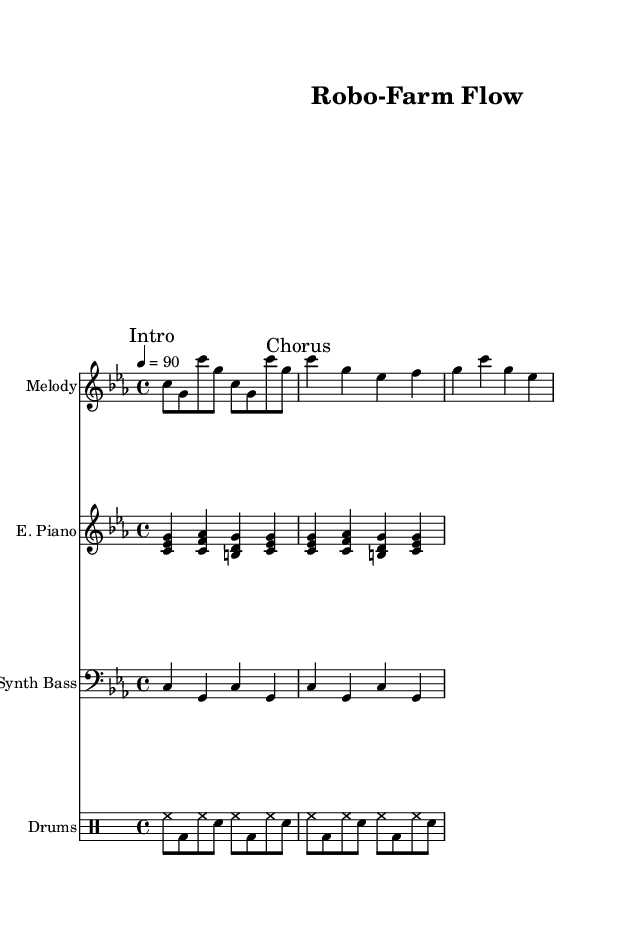What is the key signature of this music? The key signature is indicated at the beginning of the sheet music, and it shows C minor, which has three flats: B flat, E flat, and A flat.
Answer: C minor What is the time signature of this music? The time signature appears next to the key signature in the beginning section, showing it is 4/4, which means there are four beats per measure and the quarter note gets one beat.
Answer: 4/4 What is the tempo marking of this music? The tempo marking is found above the staff and is indicated by the number 90, meaning the music should be played at 90 beats per minute.
Answer: 90 How many measures are in the melody section? Counting the measures in the melody part leads to a total of four measures labeled "Intro" and four measures labeled "Chorus," resulting in eight measures overall in that section.
Answer: 8 What instruments are used in the piece? The instruments are listed at the beginning of each staff, including "Melody," "E. Piano," "Synth Bass," and "Drums," indicating a varied hip hop ensemble.
Answer: Melody, E. Piano, Synth Bass, Drums What type of musical rhythms are used in the drum section? The drum section is notated using specific symbols for hihats and snares, and it features eighth notes for hi-hats and kick drums, providing a consistent hip hop beat pattern.
Answer: Eighth notes 